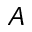<formula> <loc_0><loc_0><loc_500><loc_500>A</formula> 